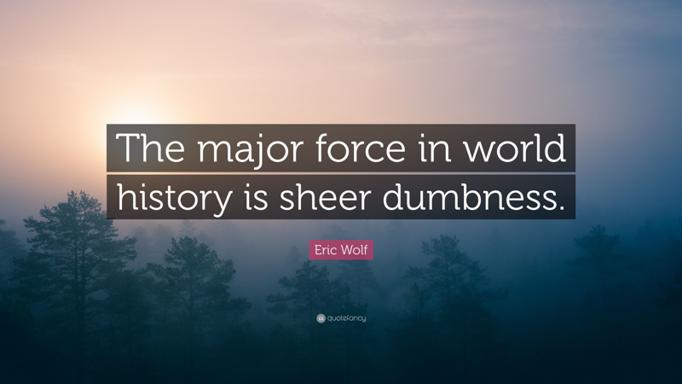Who is Eric Wolf? Eric Wolf was a prominent anthropologist, particularly known for his contributions to social anthropology. He explored how societies and cultures interface with economic and power structures, influencing global anthropology dialogues. His seminal work, 'Europe and the People Without History', challenges the Eurocentric historical narrative and offers a broader perspective on the interconnectedness of the global economy and diverse civilizations. 